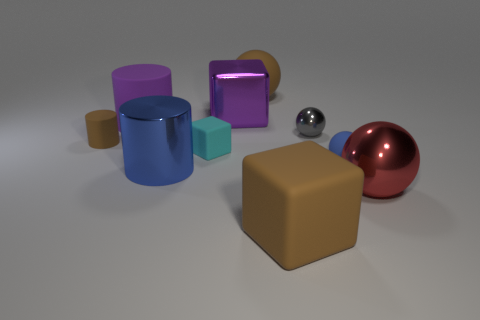There is a tiny sphere that is the same color as the metal cylinder; what is its material?
Give a very brief answer. Rubber. Is the color of the small matte thing to the right of the small shiny thing the same as the big cylinder to the left of the large blue metallic cylinder?
Offer a terse response. No. Is the number of large purple matte cylinders that are in front of the red ball greater than the number of small blocks behind the shiny cube?
Ensure brevity in your answer.  No. What color is the other large thing that is the same shape as the large blue metallic object?
Your answer should be compact. Purple. Is there any other thing that is the same shape as the gray metal thing?
Offer a terse response. Yes. Do the small cyan matte thing and the large shiny thing that is behind the purple cylinder have the same shape?
Your response must be concise. Yes. How many other things are made of the same material as the big blue cylinder?
Make the answer very short. 3. There is a tiny cylinder; does it have the same color as the sphere behind the large purple shiny thing?
Your response must be concise. Yes. What is the material of the large cylinder in front of the small gray object?
Ensure brevity in your answer.  Metal. Are there any large rubber balls of the same color as the big matte cube?
Your response must be concise. Yes. 